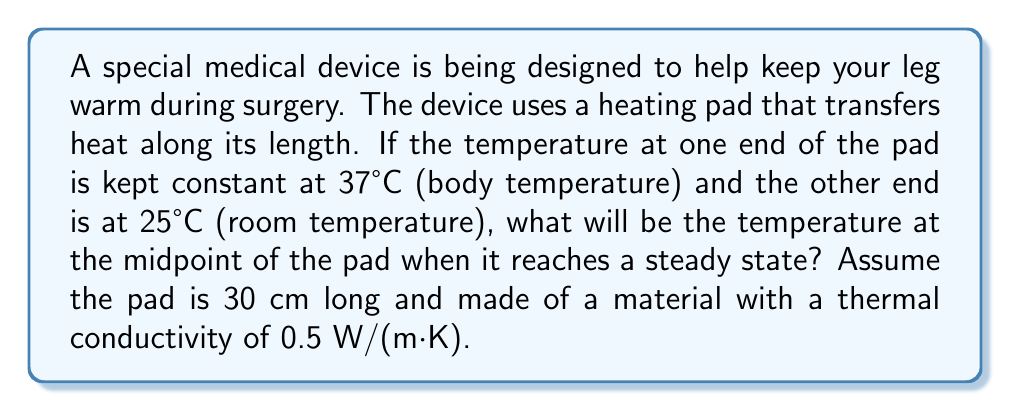Show me your answer to this math problem. Let's approach this step-by-step:

1) In a steady-state condition, the heat equation for a one-dimensional problem simplifies to:

   $$\frac{d^2T}{dx^2} = 0$$

   Where $T$ is temperature and $x$ is position along the pad.

2) The general solution to this equation is:

   $$T(x) = Ax + B$$

   Where $A$ and $B$ are constants we need to determine.

3) We have two boundary conditions:
   - At $x = 0$, $T = 37°C$
   - At $x = 30$ cm $= 0.3$ m, $T = 25°C$

4) Let's apply these conditions:
   
   For $x = 0$: $37 = A(0) + B$, so $B = 37$
   
   For $x = 0.3$: $25 = A(0.3) + 37$

5) Solving for $A$:

   $$25 = 0.3A + 37$$
   $$-12 = 0.3A$$
   $$A = -40$$

6) So our temperature distribution is:

   $$T(x) = -40x + 37$$

7) The midpoint is at $x = 15$ cm $= 0.15$ m. Let's calculate the temperature there:

   $$T(0.15) = -40(0.15) + 37 = 31°C$$

This linear temperature distribution is what we'd expect for steady-state heat conduction in a simple rod or pad.
Answer: The temperature at the midpoint of the pad will be 31°C. 